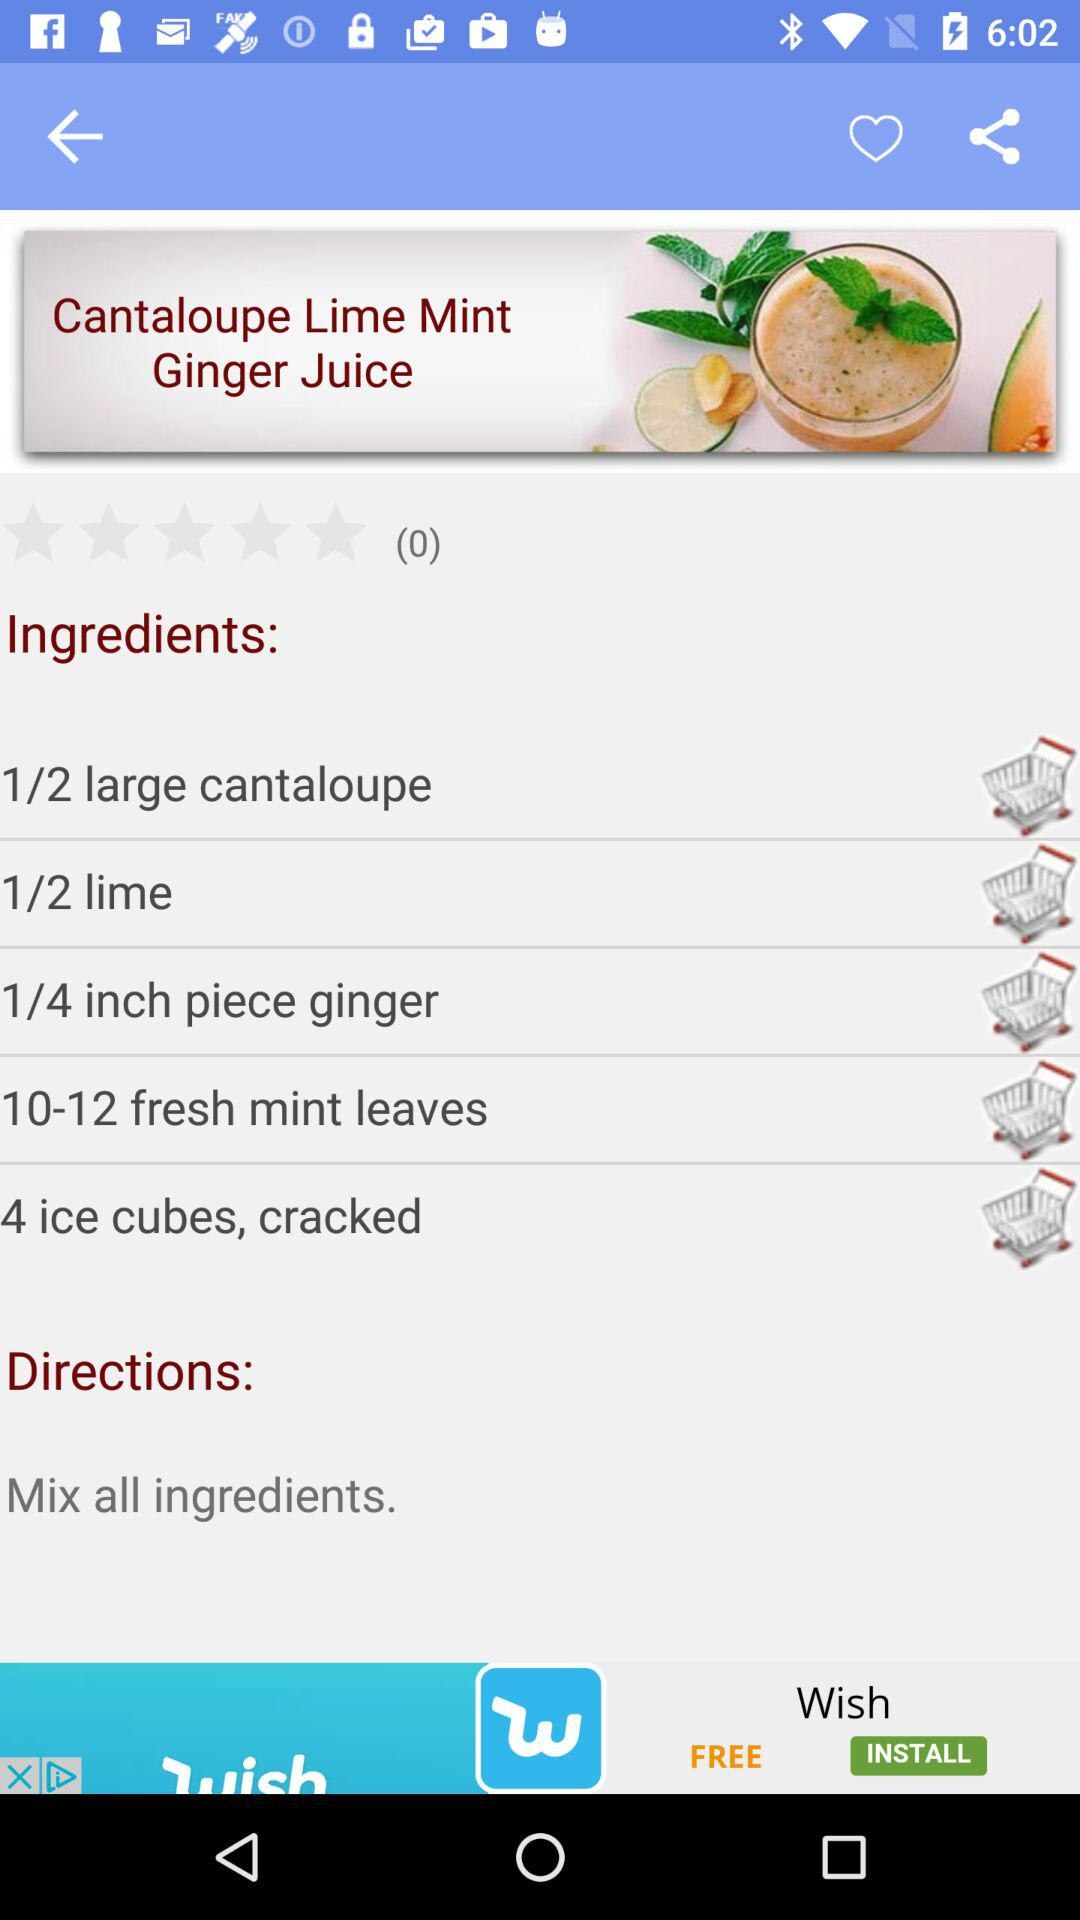How many stars are given to the recipe? The stars given to the recipe are 0. 